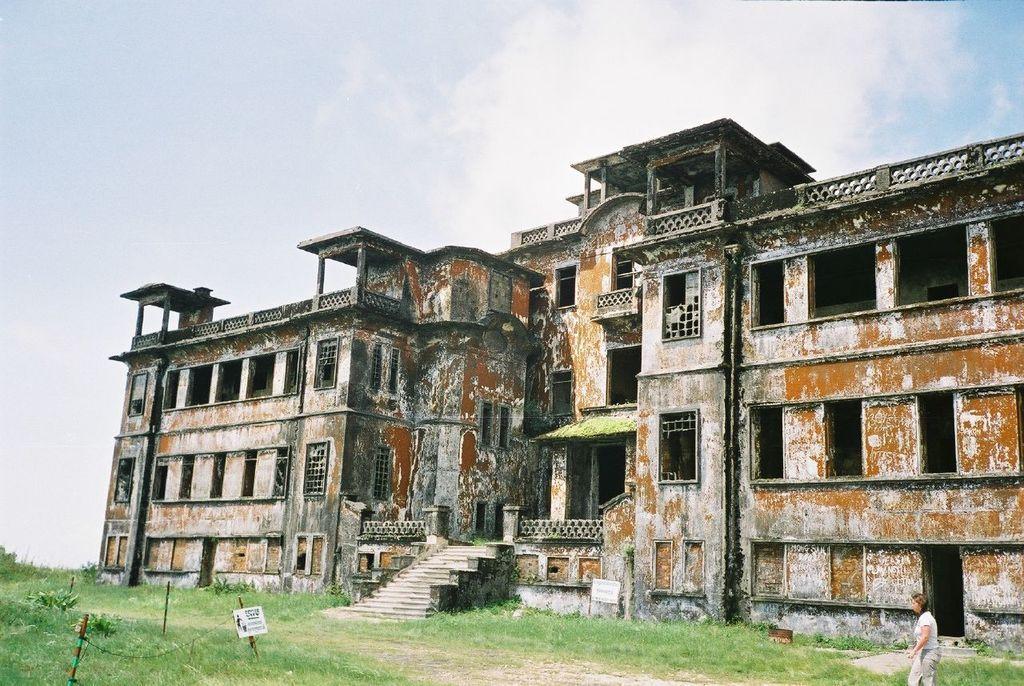How would you summarize this image in a sentence or two? In the center of the image we can see the stairs. In the background of the image we can see the buildings, windows, plants, grass, fence, board. At the bottom of the image we can see the ground. In the bottom right corner we can see a lady is walking on the ground. At the top of the image we can see the sky. 